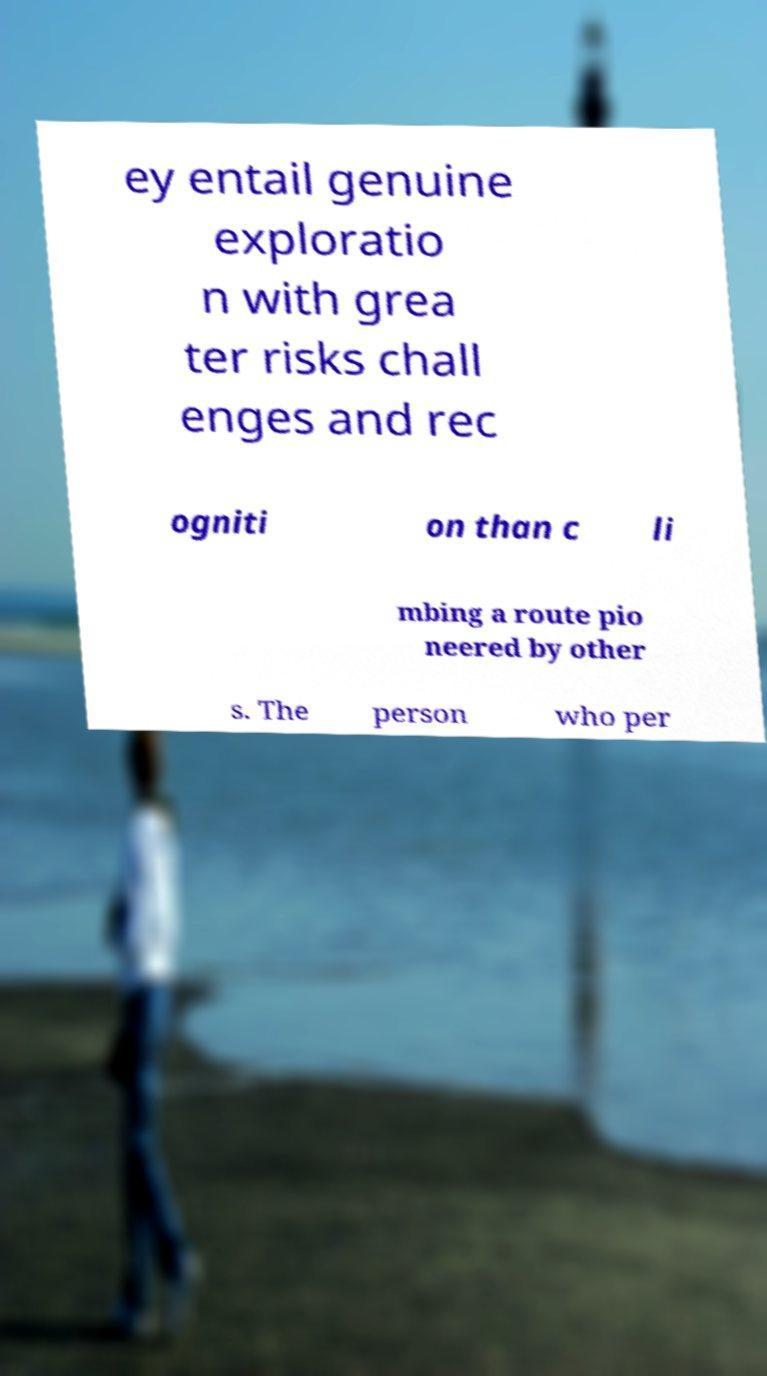There's text embedded in this image that I need extracted. Can you transcribe it verbatim? ey entail genuine exploratio n with grea ter risks chall enges and rec ogniti on than c li mbing a route pio neered by other s. The person who per 